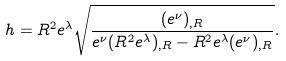<formula> <loc_0><loc_0><loc_500><loc_500>h = R ^ { 2 } e ^ { \lambda } \sqrt { \frac { ( e ^ { \nu } ) _ { , R } } { e ^ { \nu } ( R ^ { 2 } e ^ { \lambda } ) _ { , R } - R ^ { 2 } e ^ { \lambda } ( e ^ { \nu } ) _ { , R } } } .</formula> 